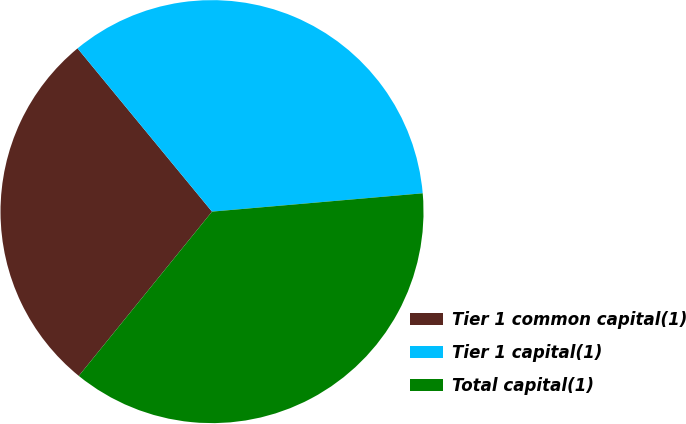Convert chart to OTSL. <chart><loc_0><loc_0><loc_500><loc_500><pie_chart><fcel>Tier 1 common capital(1)<fcel>Tier 1 capital(1)<fcel>Total capital(1)<nl><fcel>28.19%<fcel>34.58%<fcel>37.22%<nl></chart> 